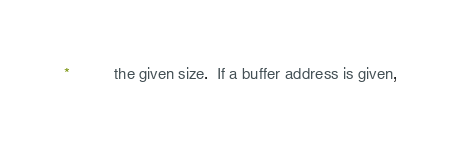Convert code to text. <code><loc_0><loc_0><loc_500><loc_500><_C_> *          the given size.  If a buffer address is given,</code> 